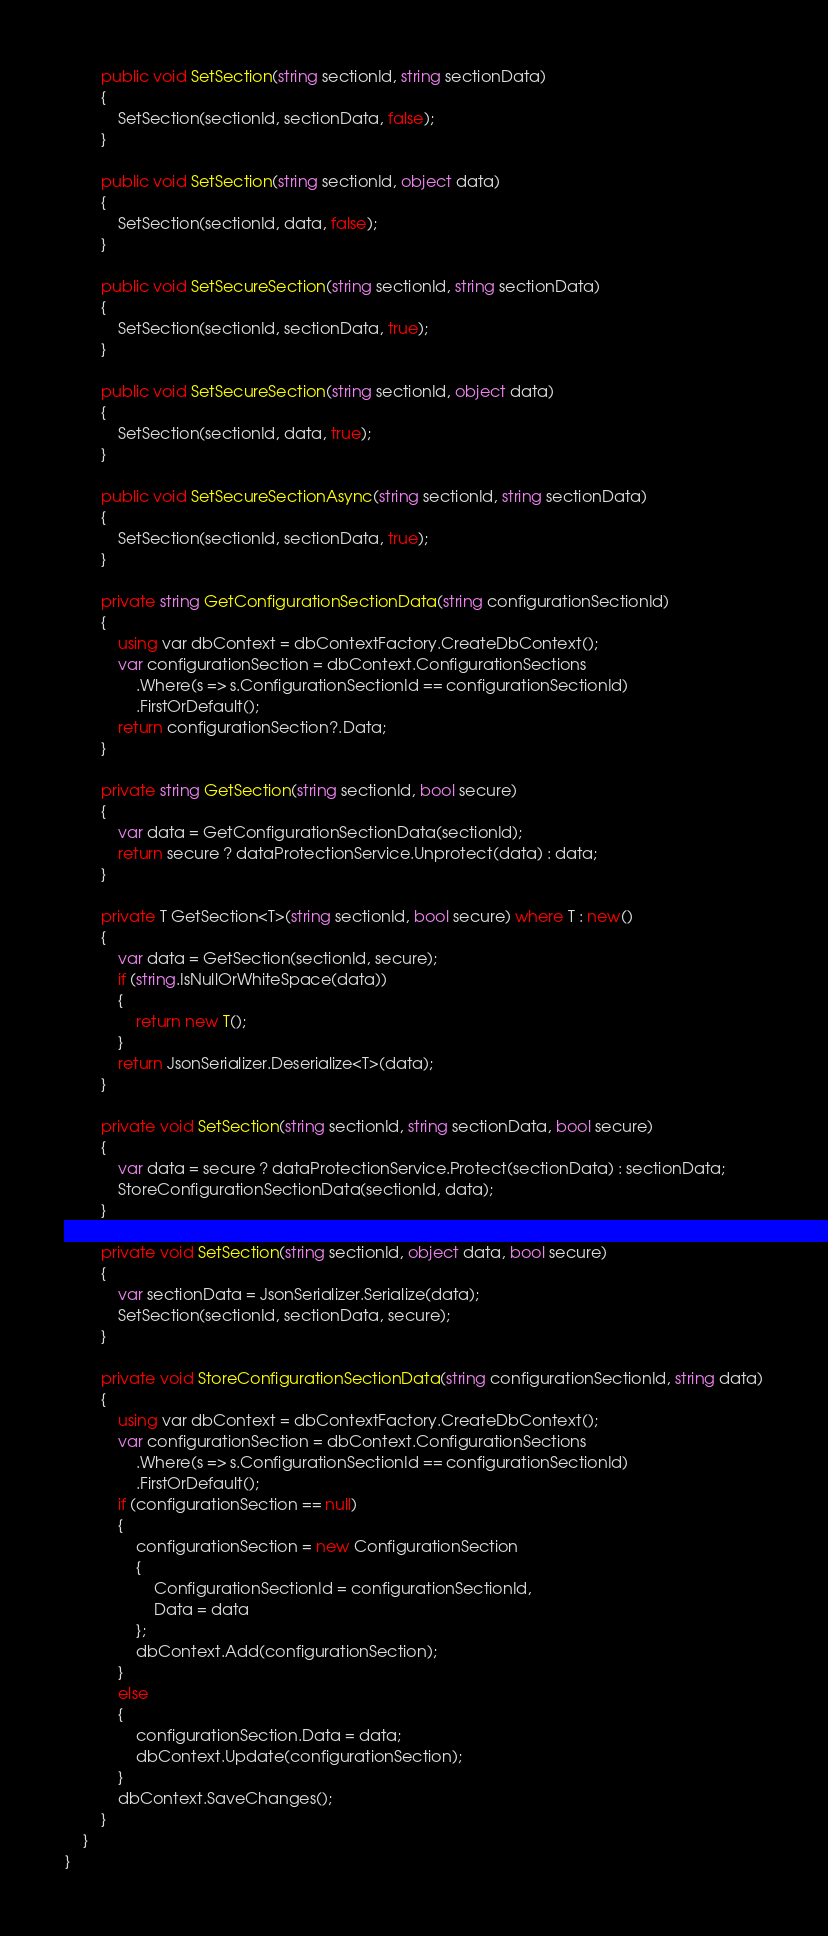Convert code to text. <code><loc_0><loc_0><loc_500><loc_500><_C#_>
        public void SetSection(string sectionId, string sectionData)
        {
            SetSection(sectionId, sectionData, false);
        }

        public void SetSection(string sectionId, object data)
        {
            SetSection(sectionId, data, false);
        }

        public void SetSecureSection(string sectionId, string sectionData)
        {
            SetSection(sectionId, sectionData, true);
        }

        public void SetSecureSection(string sectionId, object data)
        {
            SetSection(sectionId, data, true);
        }

        public void SetSecureSectionAsync(string sectionId, string sectionData)
        {
            SetSection(sectionId, sectionData, true);
        }

        private string GetConfigurationSectionData(string configurationSectionId)
        {
            using var dbContext = dbContextFactory.CreateDbContext();
            var configurationSection = dbContext.ConfigurationSections
                .Where(s => s.ConfigurationSectionId == configurationSectionId)
                .FirstOrDefault();
            return configurationSection?.Data;
        }

        private string GetSection(string sectionId, bool secure)
        {
            var data = GetConfigurationSectionData(sectionId);
            return secure ? dataProtectionService.Unprotect(data) : data;
        }

        private T GetSection<T>(string sectionId, bool secure) where T : new()
        {
            var data = GetSection(sectionId, secure);
            if (string.IsNullOrWhiteSpace(data))
            {
                return new T();
            }
            return JsonSerializer.Deserialize<T>(data);
        }

        private void SetSection(string sectionId, string sectionData, bool secure)
        {
            var data = secure ? dataProtectionService.Protect(sectionData) : sectionData;
            StoreConfigurationSectionData(sectionId, data);
        }

        private void SetSection(string sectionId, object data, bool secure)
        {
            var sectionData = JsonSerializer.Serialize(data);
            SetSection(sectionId, sectionData, secure);
        }

        private void StoreConfigurationSectionData(string configurationSectionId, string data)
        {
            using var dbContext = dbContextFactory.CreateDbContext();
            var configurationSection = dbContext.ConfigurationSections
                .Where(s => s.ConfigurationSectionId == configurationSectionId)
                .FirstOrDefault();
            if (configurationSection == null)
            {
                configurationSection = new ConfigurationSection
                {
                    ConfigurationSectionId = configurationSectionId,
                    Data = data
                };
                dbContext.Add(configurationSection);
            }
            else
            {
                configurationSection.Data = data;
                dbContext.Update(configurationSection);
            }
            dbContext.SaveChanges();
        }
    }
}
</code> 